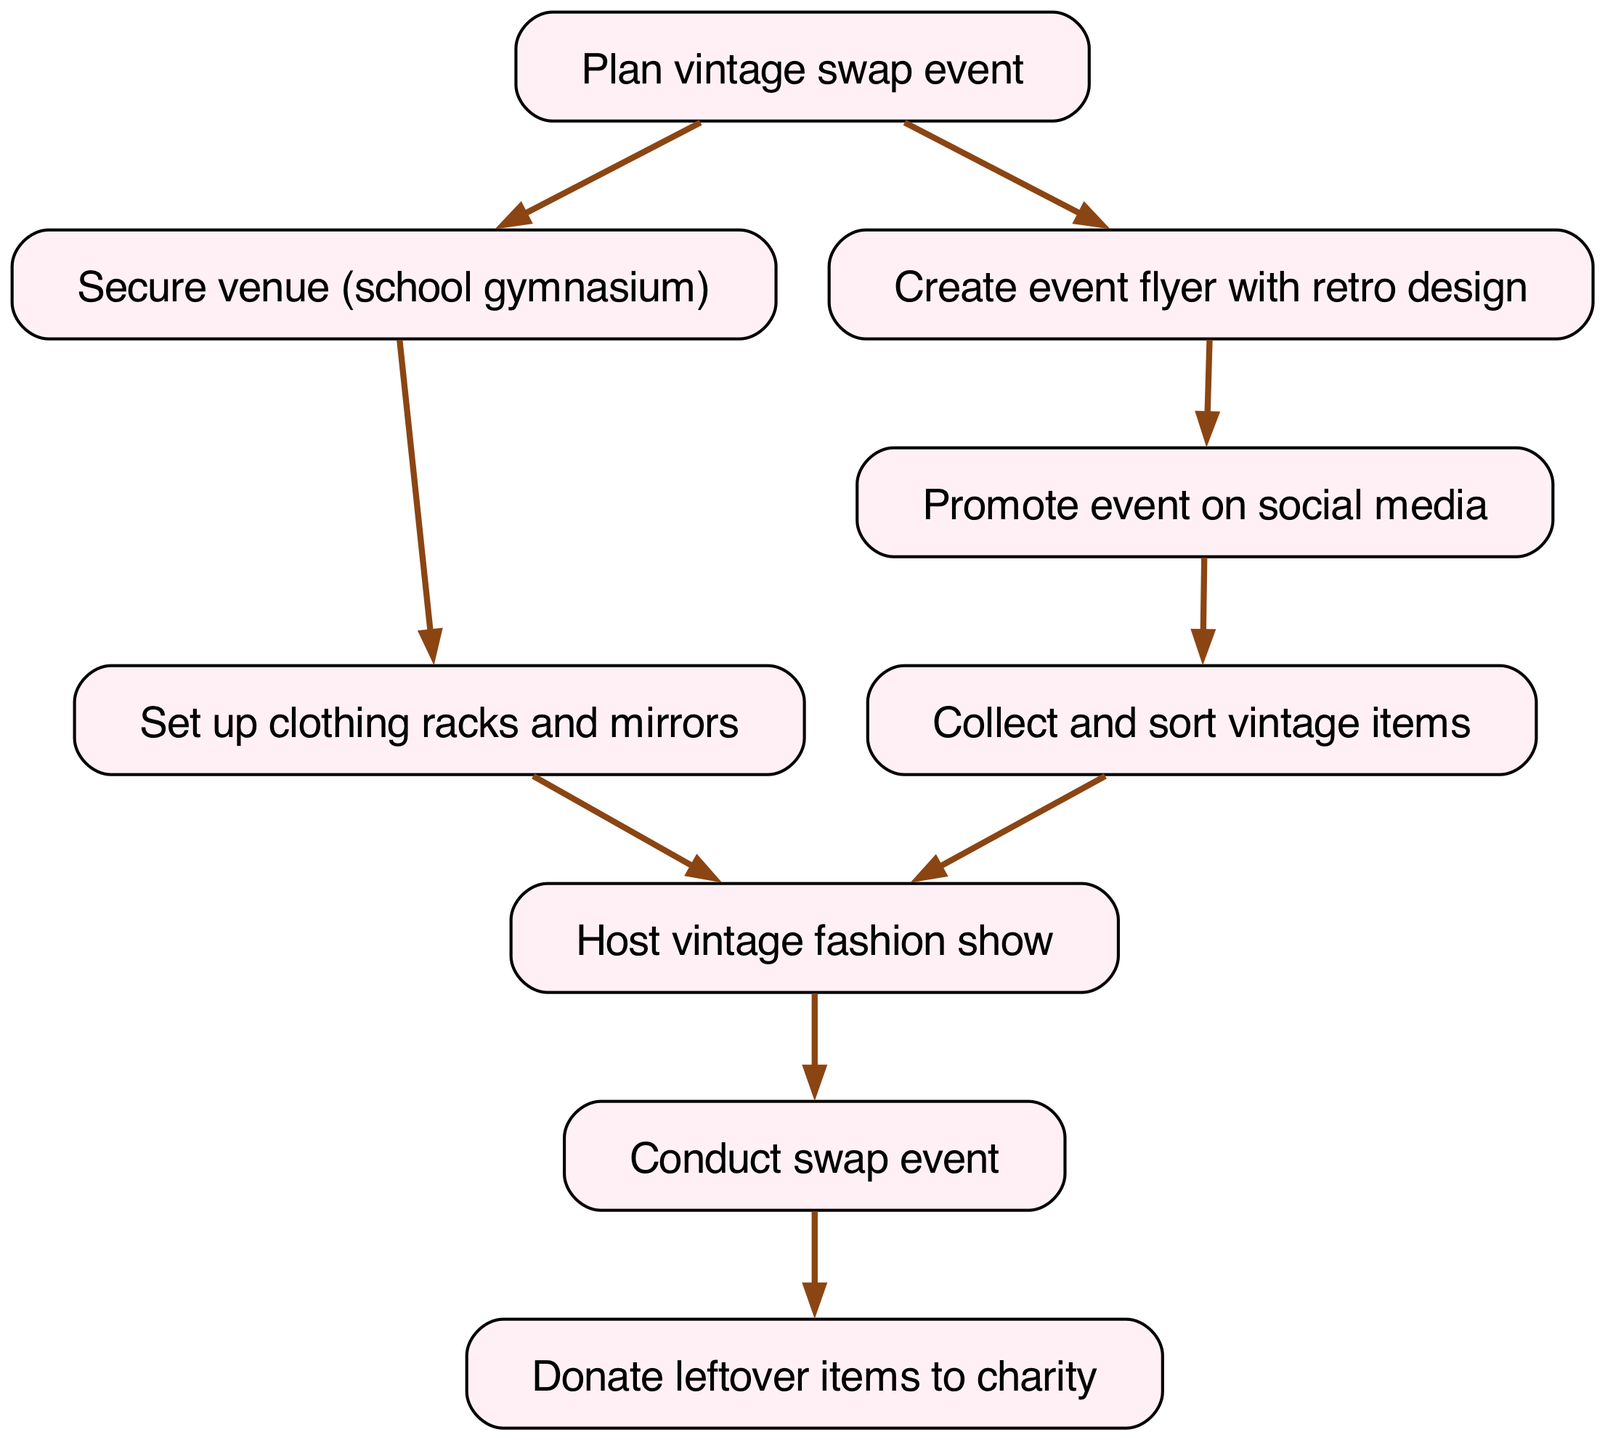What is the first step to organizing the event? The first step in the flowchart is labeled as "Plan vintage swap event," indicating that this is the initial action required.
Answer: Plan vintage swap event What follows after creating the event flyer? After "Create event flyer with retro design," the next node is "Promote event on social media," which follows directly from the flyer creation.
Answer: Promote event on social media How many nodes are present in the diagram? The diagram contains a total of 9 nodes that represent distinct steps in the process of organizing the event.
Answer: 9 What is the last action in the flow of the event? The last action depicted in the flowchart is "Donate leftover items to charity," indicating this is the final step after conducting the swap.
Answer: Donate leftover items to charity Which action occurs after securing the venue? The action that follows "Secure venue (school gymnasium)" is "Set up clothing racks and mirrors," establishing the next task in the flow after securing a location.
Answer: Set up clothing racks and mirrors Which two actions must occur before hosting the vintage fashion show? Prior to "Host vintage fashion show," both "Collect and sort vintage items" and "Set up clothing racks and mirrors" must be completed first as depicted by the flow of the diagram.
Answer: Collect and sort vintage items, Set up clothing racks and mirrors What is the relationship between promoting the event and sorting vintage items? "Promote event on social media" is followed directly by "Collect and sort vintage items," indicating that promoting the event occurs before and leads to item collection and sorting.
Answer: Promote event on social media → Collect and sort vintage items How many actions are directed towards the clothing swap event? There are three actions dedicated specifically to the actual swap event, which are "Conduct swap event," "Host vintage fashion show," and "Donate leftover items to charity."
Answer: 3 What action is mandatory before conducting the swap event? The action that is mandatory before "Conduct swap event" is "Host vintage fashion show," as the flowchart dictates that the fashion show must occur first.
Answer: Host vintage fashion show 